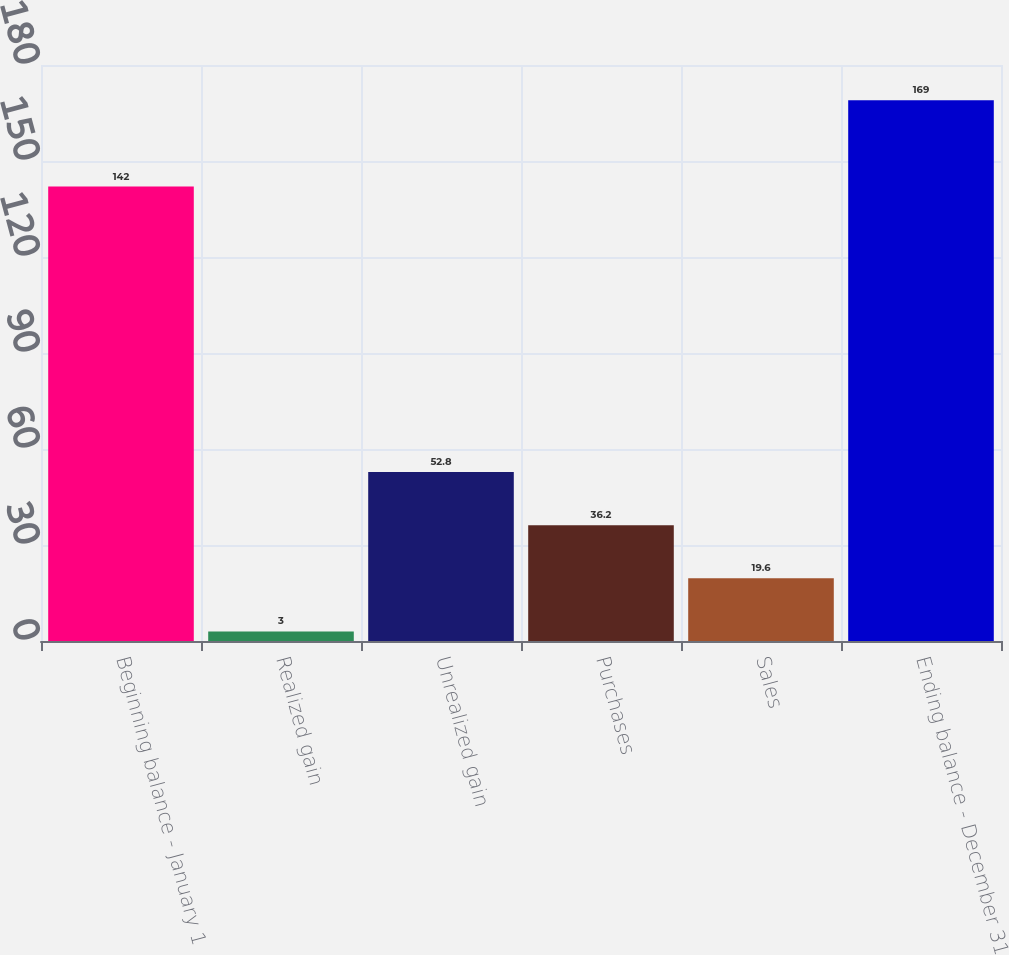Convert chart to OTSL. <chart><loc_0><loc_0><loc_500><loc_500><bar_chart><fcel>Beginning balance - January 1<fcel>Realized gain<fcel>Unrealized gain<fcel>Purchases<fcel>Sales<fcel>Ending balance - December 31<nl><fcel>142<fcel>3<fcel>52.8<fcel>36.2<fcel>19.6<fcel>169<nl></chart> 